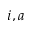<formula> <loc_0><loc_0><loc_500><loc_500>i , a</formula> 